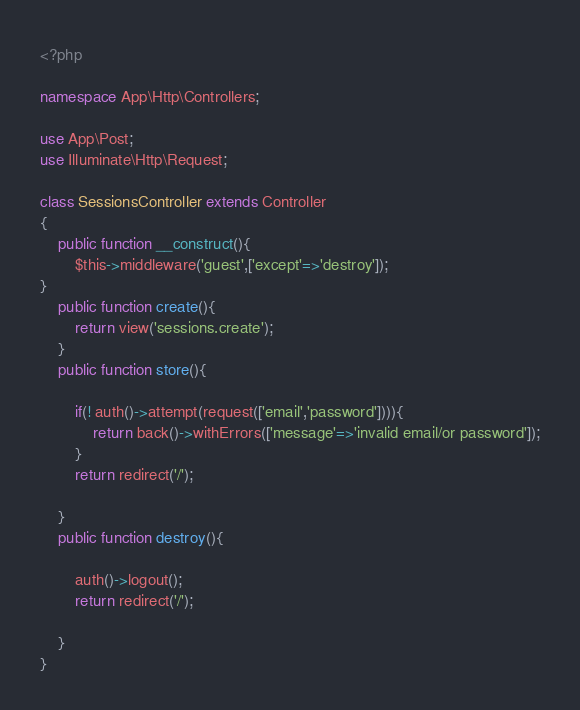<code> <loc_0><loc_0><loc_500><loc_500><_PHP_><?php

namespace App\Http\Controllers;

use App\Post;
use Illuminate\Http\Request;

class SessionsController extends Controller
{
    public function __construct(){
        $this->middleware('guest',['except'=>'destroy']);
}
    public function create(){
        return view('sessions.create');
    }
    public function store(){

        if(! auth()->attempt(request(['email','password']))){
            return back()->withErrors(['message'=>'invalid email/or password']);
        }
        return redirect('/');

    }
    public function destroy(){

        auth()->logout();
        return redirect('/');

    }
}
</code> 